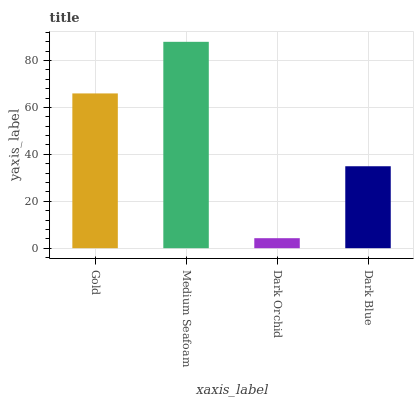Is Dark Orchid the minimum?
Answer yes or no. Yes. Is Medium Seafoam the maximum?
Answer yes or no. Yes. Is Medium Seafoam the minimum?
Answer yes or no. No. Is Dark Orchid the maximum?
Answer yes or no. No. Is Medium Seafoam greater than Dark Orchid?
Answer yes or no. Yes. Is Dark Orchid less than Medium Seafoam?
Answer yes or no. Yes. Is Dark Orchid greater than Medium Seafoam?
Answer yes or no. No. Is Medium Seafoam less than Dark Orchid?
Answer yes or no. No. Is Gold the high median?
Answer yes or no. Yes. Is Dark Blue the low median?
Answer yes or no. Yes. Is Dark Blue the high median?
Answer yes or no. No. Is Gold the low median?
Answer yes or no. No. 